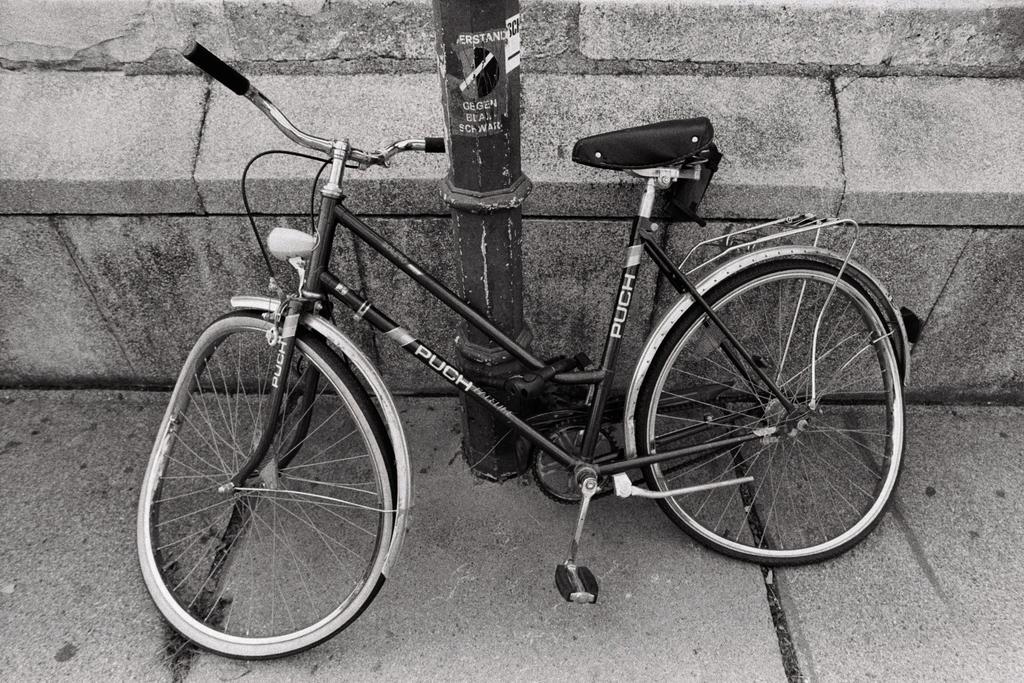Could you give a brief overview of what you see in this image? It is a black and white image. In this image we can see a bicycle on the path. In the background there is a pole and also the wall. 